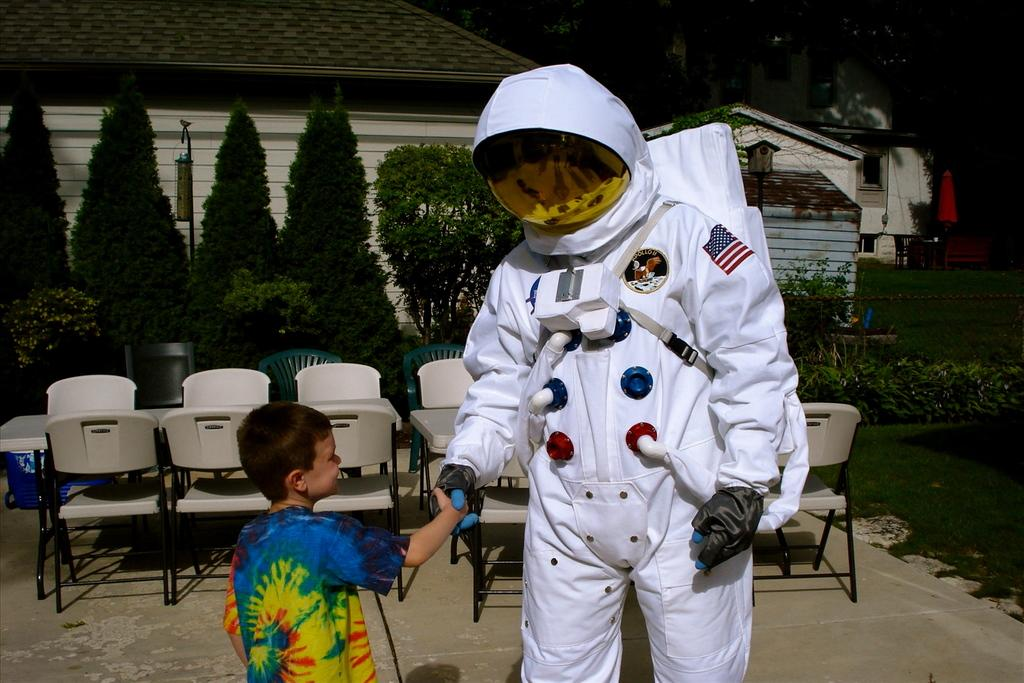What is the person in the image wearing? The person in the image is wearing a space costume. What part of the costume can be seen on the person's hands? The person is wearing gloves on their hands. What is the person doing with the boy in the image? The person is shaking hands with a boy. What can be seen in the background of the image? There is a table, chairs, trees, a house, and grass in the background of the image. How does the person in the space costume help the boy with their homework in the image? There is no indication in the image that the person in the space costume is helping the boy with homework, as the image only shows them shaking hands. 